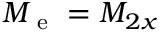<formula> <loc_0><loc_0><loc_500><loc_500>M _ { e } = M _ { 2 x }</formula> 